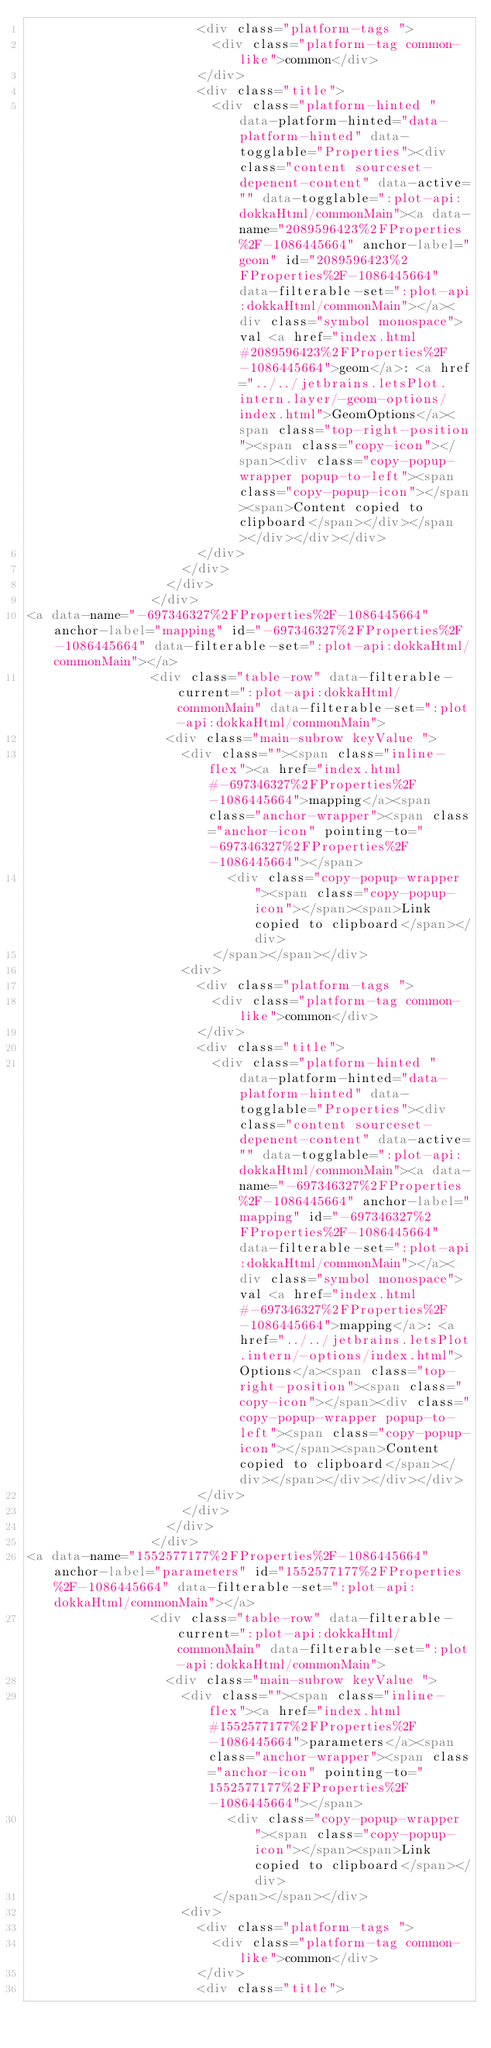Convert code to text. <code><loc_0><loc_0><loc_500><loc_500><_HTML_>                      <div class="platform-tags ">
                        <div class="platform-tag common-like">common</div>
                      </div>
                      <div class="title">
                        <div class="platform-hinted " data-platform-hinted="data-platform-hinted" data-togglable="Properties"><div class="content sourceset-depenent-content" data-active="" data-togglable=":plot-api:dokkaHtml/commonMain"><a data-name="2089596423%2FProperties%2F-1086445664" anchor-label="geom" id="2089596423%2FProperties%2F-1086445664" data-filterable-set=":plot-api:dokkaHtml/commonMain"></a><div class="symbol monospace">val <a href="index.html#2089596423%2FProperties%2F-1086445664">geom</a>: <a href="../../jetbrains.letsPlot.intern.layer/-geom-options/index.html">GeomOptions</a><span class="top-right-position"><span class="copy-icon"></span><div class="copy-popup-wrapper popup-to-left"><span class="copy-popup-icon"></span><span>Content copied to clipboard</span></div></span></div></div></div>
                      </div>
                    </div>
                  </div>
                </div>
<a data-name="-697346327%2FProperties%2F-1086445664" anchor-label="mapping" id="-697346327%2FProperties%2F-1086445664" data-filterable-set=":plot-api:dokkaHtml/commonMain"></a>
                <div class="table-row" data-filterable-current=":plot-api:dokkaHtml/commonMain" data-filterable-set=":plot-api:dokkaHtml/commonMain">
                  <div class="main-subrow keyValue ">
                    <div class=""><span class="inline-flex"><a href="index.html#-697346327%2FProperties%2F-1086445664">mapping</a><span class="anchor-wrapper"><span class="anchor-icon" pointing-to="-697346327%2FProperties%2F-1086445664"></span>
                          <div class="copy-popup-wrapper "><span class="copy-popup-icon"></span><span>Link copied to clipboard</span></div>
                        </span></span></div>
                    <div>
                      <div class="platform-tags ">
                        <div class="platform-tag common-like">common</div>
                      </div>
                      <div class="title">
                        <div class="platform-hinted " data-platform-hinted="data-platform-hinted" data-togglable="Properties"><div class="content sourceset-depenent-content" data-active="" data-togglable=":plot-api:dokkaHtml/commonMain"><a data-name="-697346327%2FProperties%2F-1086445664" anchor-label="mapping" id="-697346327%2FProperties%2F-1086445664" data-filterable-set=":plot-api:dokkaHtml/commonMain"></a><div class="symbol monospace">val <a href="index.html#-697346327%2FProperties%2F-1086445664">mapping</a>: <a href="../../jetbrains.letsPlot.intern/-options/index.html">Options</a><span class="top-right-position"><span class="copy-icon"></span><div class="copy-popup-wrapper popup-to-left"><span class="copy-popup-icon"></span><span>Content copied to clipboard</span></div></span></div></div></div>
                      </div>
                    </div>
                  </div>
                </div>
<a data-name="1552577177%2FProperties%2F-1086445664" anchor-label="parameters" id="1552577177%2FProperties%2F-1086445664" data-filterable-set=":plot-api:dokkaHtml/commonMain"></a>
                <div class="table-row" data-filterable-current=":plot-api:dokkaHtml/commonMain" data-filterable-set=":plot-api:dokkaHtml/commonMain">
                  <div class="main-subrow keyValue ">
                    <div class=""><span class="inline-flex"><a href="index.html#1552577177%2FProperties%2F-1086445664">parameters</a><span class="anchor-wrapper"><span class="anchor-icon" pointing-to="1552577177%2FProperties%2F-1086445664"></span>
                          <div class="copy-popup-wrapper "><span class="copy-popup-icon"></span><span>Link copied to clipboard</span></div>
                        </span></span></div>
                    <div>
                      <div class="platform-tags ">
                        <div class="platform-tag common-like">common</div>
                      </div>
                      <div class="title"></code> 